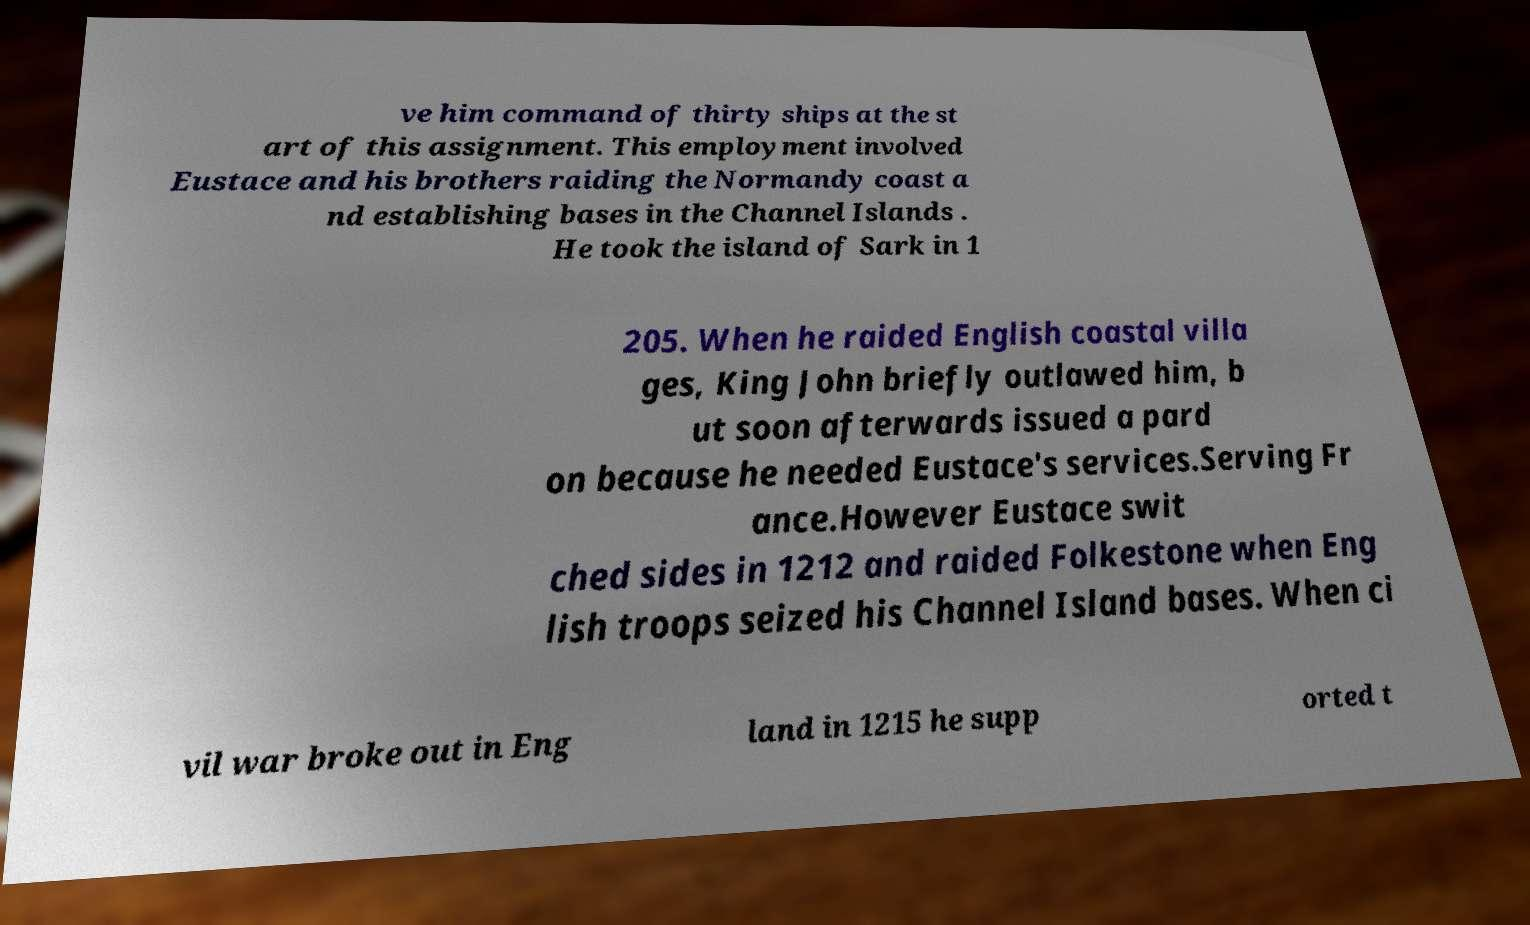Could you assist in decoding the text presented in this image and type it out clearly? ve him command of thirty ships at the st art of this assignment. This employment involved Eustace and his brothers raiding the Normandy coast a nd establishing bases in the Channel Islands . He took the island of Sark in 1 205. When he raided English coastal villa ges, King John briefly outlawed him, b ut soon afterwards issued a pard on because he needed Eustace's services.Serving Fr ance.However Eustace swit ched sides in 1212 and raided Folkestone when Eng lish troops seized his Channel Island bases. When ci vil war broke out in Eng land in 1215 he supp orted t 